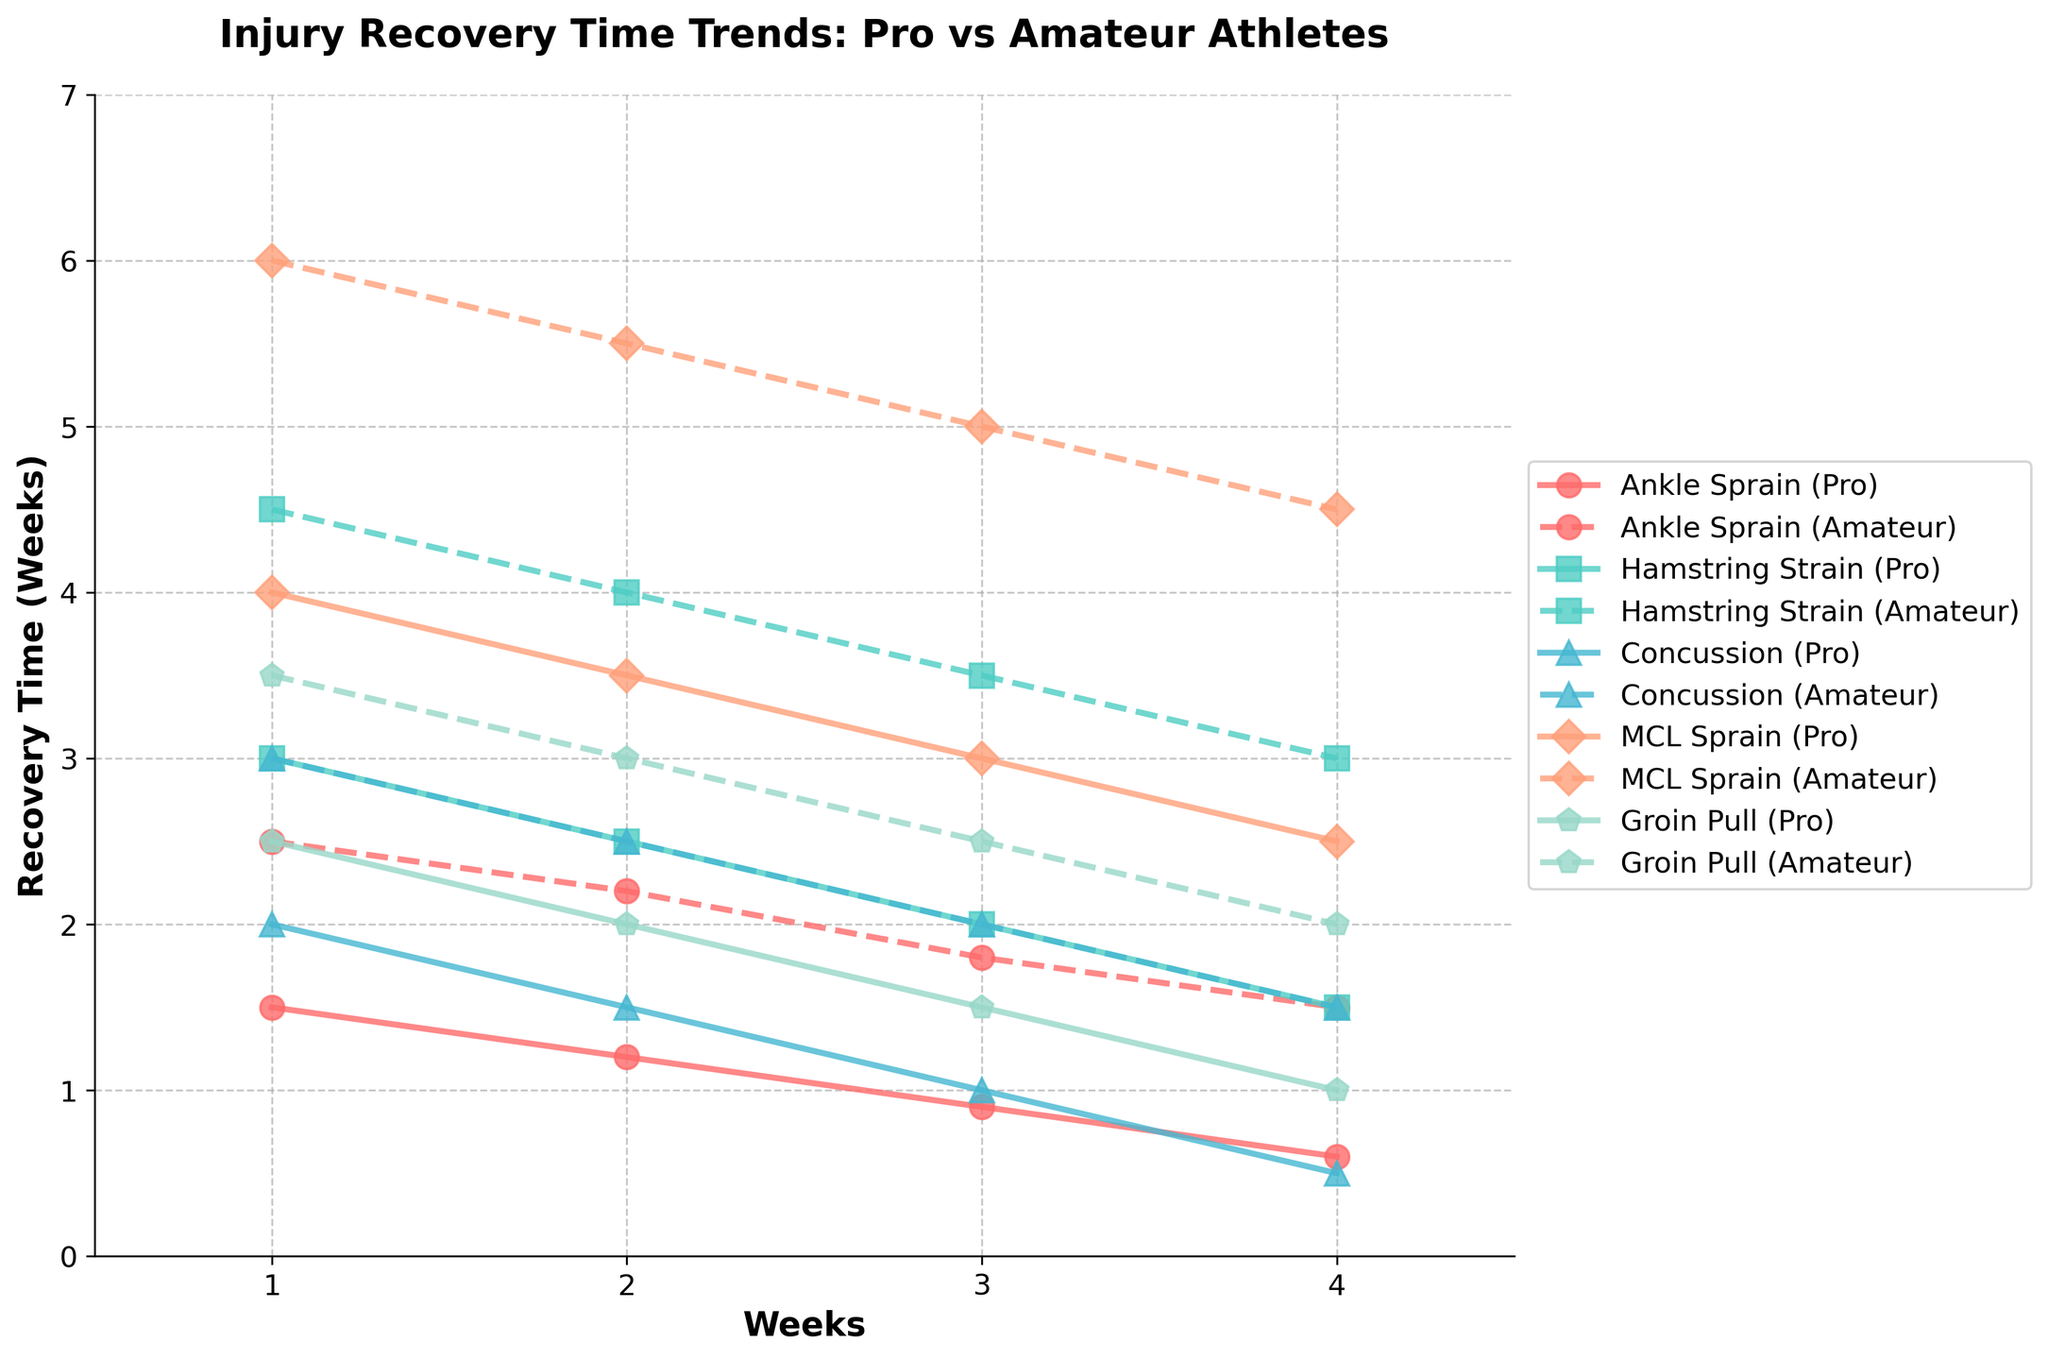Which injury has the fastest recovery time by week 4 for professional athletes? Look at the lines representing professional athletes and find the injury with the lowest recovery time in week 4. It appears to be the line that drops to the lowest point.
Answer: Concussion Which injury shows the greatest difference in recovery time between professional and amateur athletes in week 1? Compare the starting points of each injury's lines for professionals and amateurs in week 1. Find the one with the largest vertical gap.
Answer: MCL Sprain What is the average recovery time for amateur athletes with an ankle sprain over the 4 weeks? Sum the recovery times for amateur athletes with an ankle sprain and divide by 4: (2.5 + 2.2 + 1.8 + 1.5) / 4 = 2.
Answer: 2 weeks Which injury has the smallest difference in recovery time between professional and amateur athletes by week 3? Compare the recovery times for pros and amateurs in week 3 by measuring the gaps between lines. Identify the injury with the smallest gap.
Answer: Concussion Between hamstring strain and groin pull, which injury has a shorter recovery time in week 2 for professional athletes? Check the recovery times for professional athletes in week 2 for both injuries. The line with the lower value indicates the shorter recovery time.
Answer: Groin Pull For professional athletes, which injury shows the steepest decline in recovery time from week 1 to week 4? Identify the line that descends the most sharply from week 1 to week 4, indicating a steeper decline. Measure the total drop for each injury.
Answer: Ankle Sprain What is the combined recovery time for amateur athletes with an MCL sprain and groin pull in week 3? Add the recovery times for MCL sprain and groin pull for amateur athletes in week 3: 5.0 + 2.5 = 7.5.
Answer: 7.5 weeks How does the recovery time trend for a hamstring strain differ between professional and amateur athletes over the 4 weeks? Observe the shapes and slopes of the lines representing hamstring strain for both groups over time. Professionals show a steady decline, while amateurs have a slower descent.
Answer: Pros show a steady decline; amateurs slower Comparing professional athletes, which injury has a longer recovery time at week 2, MCL sprain or hamstring strain? Look at the week 2 recovery times for professionals for both injuries and compare the values. MCL sprain has a higher value than hamstring strain.
Answer: MCL Sprain 